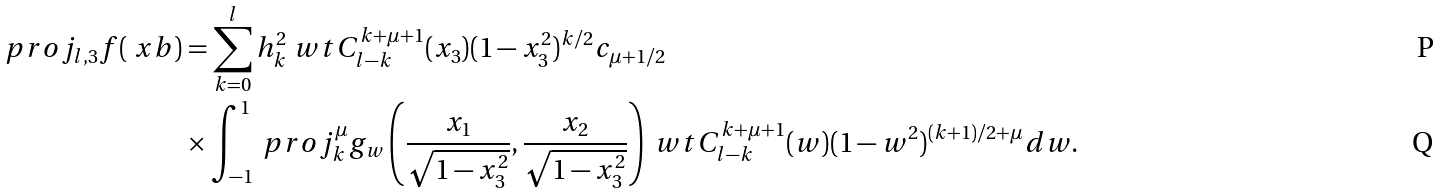Convert formula to latex. <formula><loc_0><loc_0><loc_500><loc_500>\ p r o j _ { l , 3 } f ( \ x b ) & = \sum _ { k = 0 } ^ { l } h _ { k } ^ { 2 } \ w t C _ { l - k } ^ { k + \mu + 1 } ( x _ { 3 } ) ( 1 - x _ { 3 } ^ { 2 } ) ^ { k / 2 } c _ { \mu + 1 / 2 } \\ & \times \int _ { - 1 } ^ { 1 } \ p r o j _ { k } ^ { \mu } g _ { w } \left ( \frac { x _ { 1 } } { \sqrt { 1 - x _ { 3 } ^ { 2 } } } , \frac { x _ { 2 } } { \sqrt { 1 - x _ { 3 } ^ { 2 } } } \right ) \ w t C _ { l - k } ^ { k + \mu + 1 } ( w ) ( 1 - w ^ { 2 } ) ^ { ( k + 1 ) / 2 + \mu } d w .</formula> 